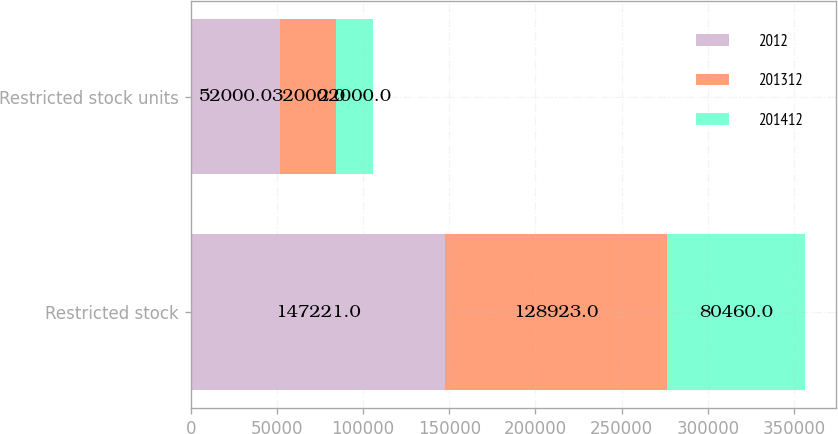Convert chart. <chart><loc_0><loc_0><loc_500><loc_500><stacked_bar_chart><ecel><fcel>Restricted stock<fcel>Restricted stock units<nl><fcel>2012<fcel>147221<fcel>52000<nl><fcel>201312<fcel>128923<fcel>32000<nl><fcel>201412<fcel>80460<fcel>22000<nl></chart> 